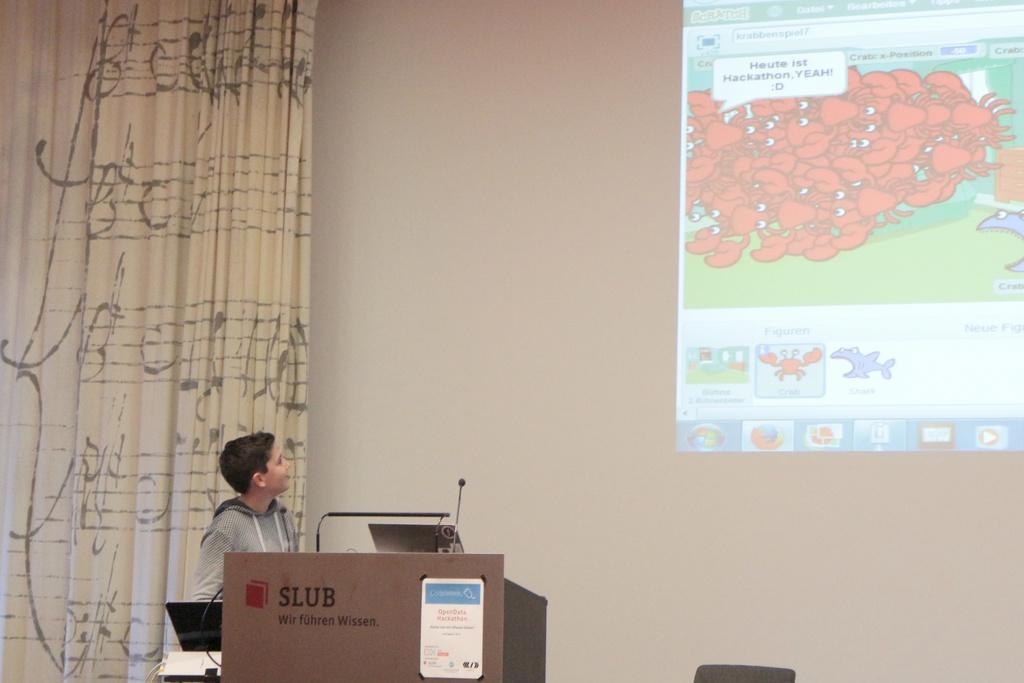Can you describe this image briefly? In this image, we can see a projection on the wall. There is a curtain on the left side of the image. There is a kid and podium at the bottom of the image. 